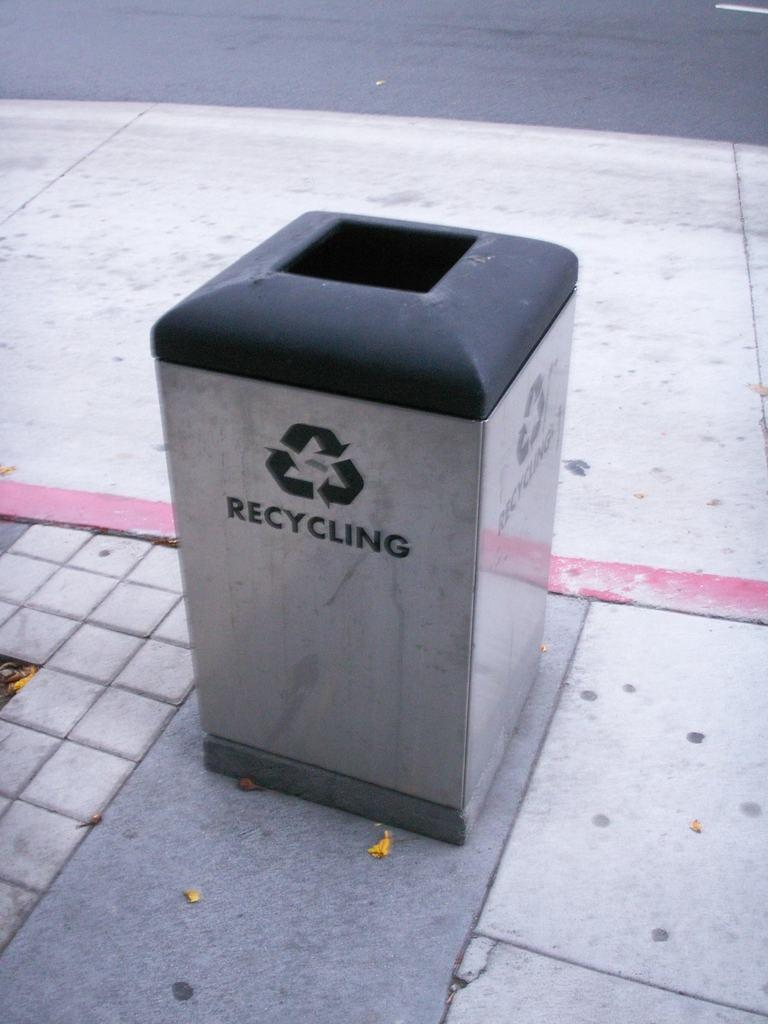<image>
Present a compact description of the photo's key features. Garbage can outside which has the word RECYCLING on the front. 